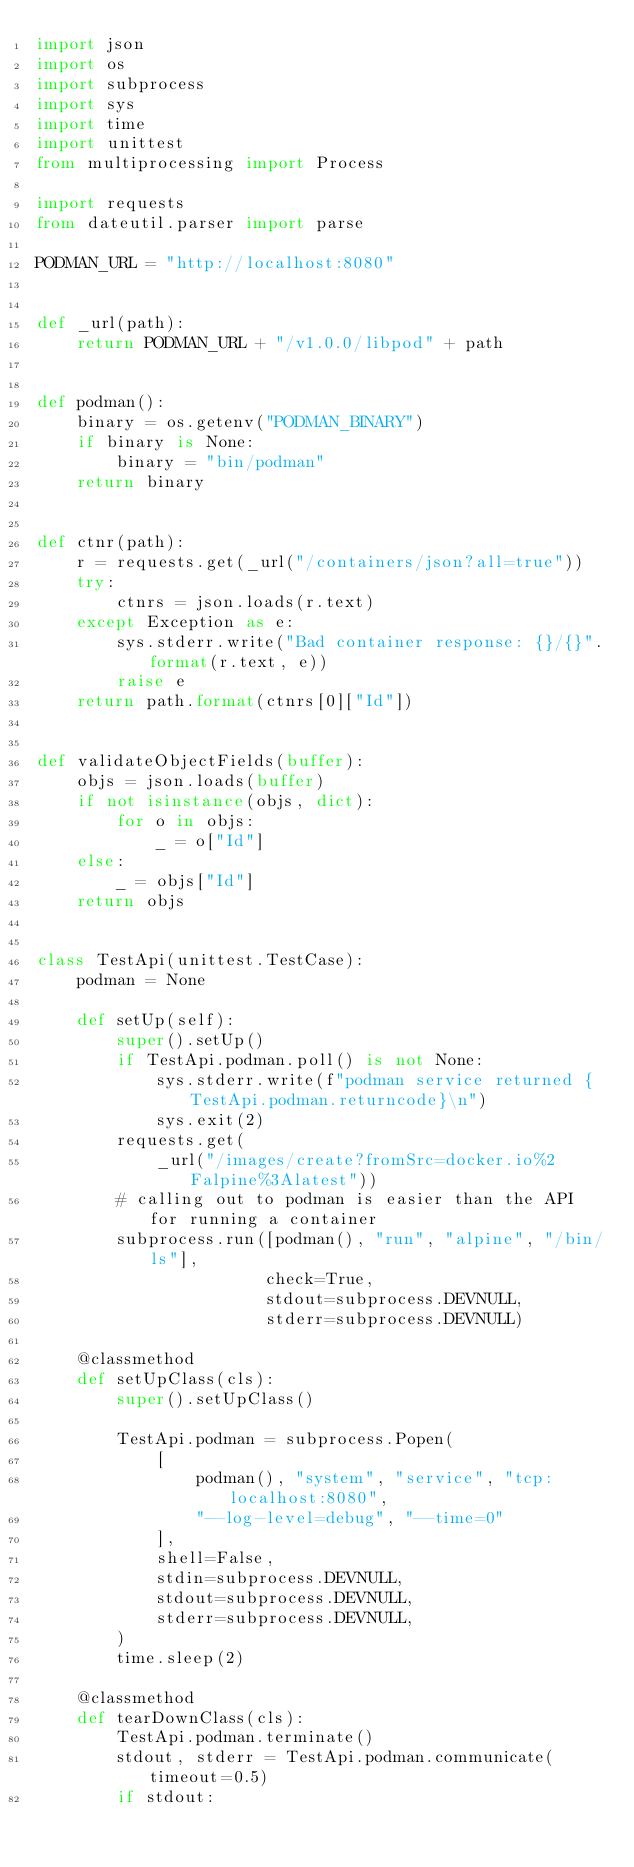<code> <loc_0><loc_0><loc_500><loc_500><_Python_>import json
import os
import subprocess
import sys
import time
import unittest
from multiprocessing import Process

import requests
from dateutil.parser import parse

PODMAN_URL = "http://localhost:8080"


def _url(path):
    return PODMAN_URL + "/v1.0.0/libpod" + path


def podman():
    binary = os.getenv("PODMAN_BINARY")
    if binary is None:
        binary = "bin/podman"
    return binary


def ctnr(path):
    r = requests.get(_url("/containers/json?all=true"))
    try:
        ctnrs = json.loads(r.text)
    except Exception as e:
        sys.stderr.write("Bad container response: {}/{}".format(r.text, e))
        raise e
    return path.format(ctnrs[0]["Id"])


def validateObjectFields(buffer):
    objs = json.loads(buffer)
    if not isinstance(objs, dict):
        for o in objs:
            _ = o["Id"]
    else:
        _ = objs["Id"]
    return objs


class TestApi(unittest.TestCase):
    podman = None

    def setUp(self):
        super().setUp()
        if TestApi.podman.poll() is not None:
            sys.stderr.write(f"podman service returned {TestApi.podman.returncode}\n")
            sys.exit(2)
        requests.get(
            _url("/images/create?fromSrc=docker.io%2Falpine%3Alatest"))
        # calling out to podman is easier than the API for running a container
        subprocess.run([podman(), "run", "alpine", "/bin/ls"],
                       check=True,
                       stdout=subprocess.DEVNULL,
                       stderr=subprocess.DEVNULL)

    @classmethod
    def setUpClass(cls):
        super().setUpClass()

        TestApi.podman = subprocess.Popen(
            [
                podman(), "system", "service", "tcp:localhost:8080",
                "--log-level=debug", "--time=0"
            ],
            shell=False,
            stdin=subprocess.DEVNULL,
            stdout=subprocess.DEVNULL,
            stderr=subprocess.DEVNULL,
        )
        time.sleep(2)

    @classmethod
    def tearDownClass(cls):
        TestApi.podman.terminate()
        stdout, stderr = TestApi.podman.communicate(timeout=0.5)
        if stdout:</code> 